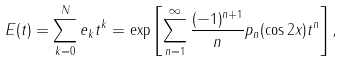<formula> <loc_0><loc_0><loc_500><loc_500>E ( t ) = \sum _ { k = 0 } ^ { N } e _ { k } t ^ { k } = \exp \left [ \sum _ { n = 1 } ^ { \infty } \frac { ( - 1 ) ^ { n + 1 } } { n } p _ { n } ( \cos 2 x ) t ^ { n } \right ] ,</formula> 